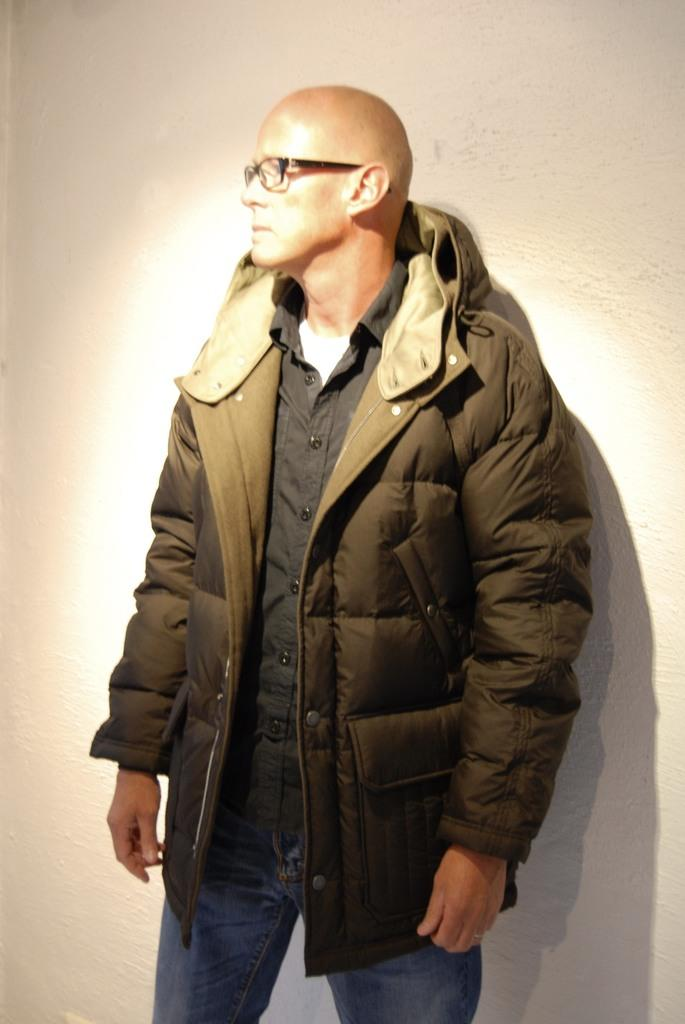Who is the main subject in the image? There is a man in the image. What is the man doing in the image? The man is posing for a photo. What type of clothing is the man wearing in the image? The man is wearing a jacket. What accessory is the man wearing in the image? The man is wearing spectacles. What does the man's son say about the photo in the image? There is no mention of a son or any dialogue in the image, so it cannot be determined what the son might say about the photo. 